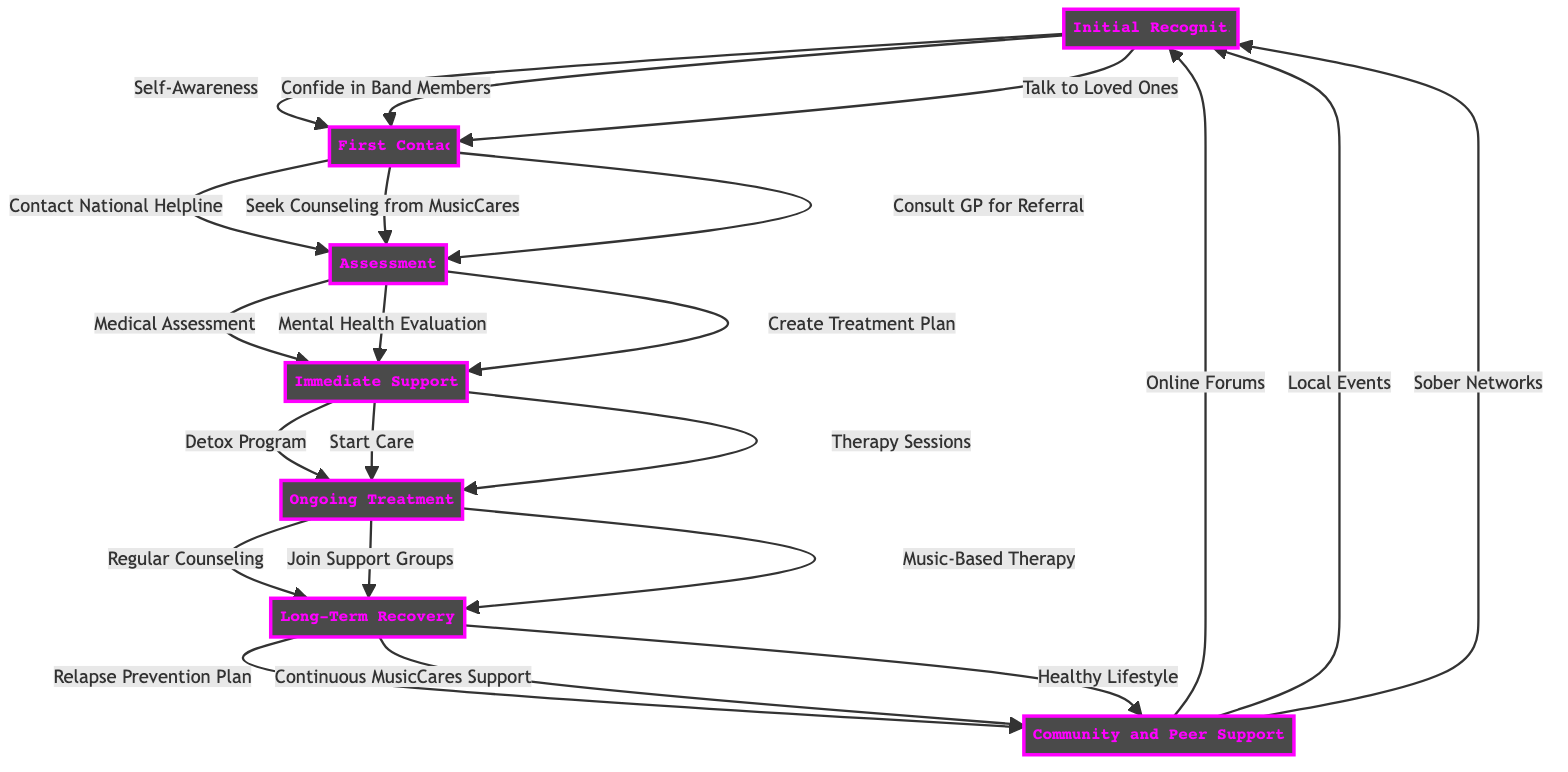What is the first stage in the pathway? The first stage is labeled "Initial Recognition" in the diagram, representing the starting point of the support process for musicians.
Answer: Initial Recognition How many actions are included in the "Immediate Support" stage? The "Immediate Support" stage includes three distinct actions, which are listed in the diagram.
Answer: 3 What action is taken after "Consult GP for Referral"? Following "Consult GP for Referral," the next stage is "Assessment," indicating the subsequent step after this action.
Answer: Assessment Which stage involves creating a customized treatment plan? The "Assessment" stage involves creating a customized treatment plan as one of its actions, shown in the diagram.
Answer: Assessment What is the final stage in the pathway? The last stage in the pathway is "Community and Peer Support," which concludes the process of substance abuse support for musicians.
Answer: Community and Peer Support During which stage do musicians join support groups? Musicians join support groups during the "Ongoing Treatment" stage, where regular counseling and support are emphasized.
Answer: Ongoing Treatment How many total stages are presented in the diagram? The diagram outlines a total of seven stages, each representing a different part of the substance abuse support pathway for musicians.
Answer: 7 What is the action after "Start Outpatient/Inpatient Care"? The action that follows "Start Outpatient/Inpatient Care" is "Engage in Therapy Sessions," forming part of the immediate support measures.
Answer: Engage in Therapy Sessions What type of support is featured in the "Long-Term Recovery" stage? The "Long-Term Recovery" stage includes continuous support from MusicCares, highlighting the role of ongoing assistance in maintaining sobriety.
Answer: Continuous Support from MusicCares 